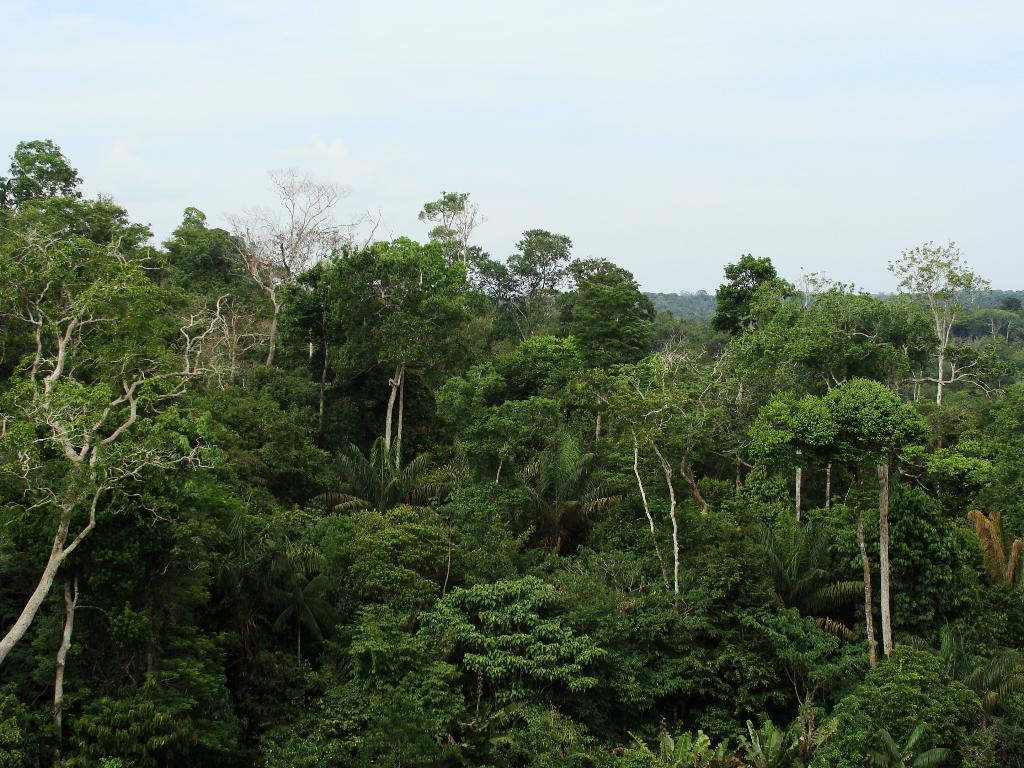How would you summarize this image in a sentence or two? In this image, we can see trees. At the top, there is sky. 